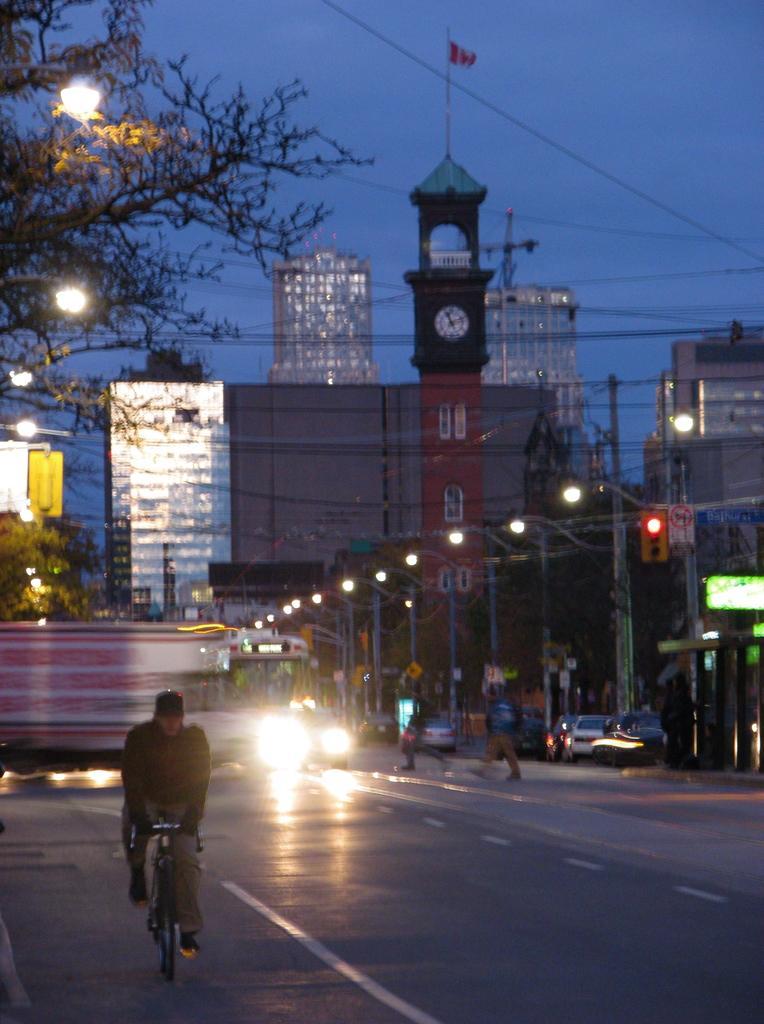Could you give a brief overview of what you see in this image? There is a man riding bicycle behind him there is a bus coming and tree at back and a building with lights and a big clock tower and some street lights and few people crossing lights. 